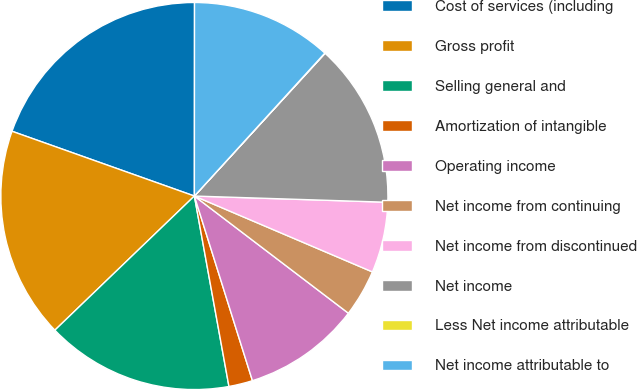Convert chart to OTSL. <chart><loc_0><loc_0><loc_500><loc_500><pie_chart><fcel>Cost of services (including<fcel>Gross profit<fcel>Selling general and<fcel>Amortization of intangible<fcel>Operating income<fcel>Net income from continuing<fcel>Net income from discontinued<fcel>Net income<fcel>Less Net income attributable<fcel>Net income attributable to<nl><fcel>19.58%<fcel>17.62%<fcel>15.67%<fcel>1.99%<fcel>9.8%<fcel>3.94%<fcel>5.9%<fcel>13.71%<fcel>0.03%<fcel>11.76%<nl></chart> 